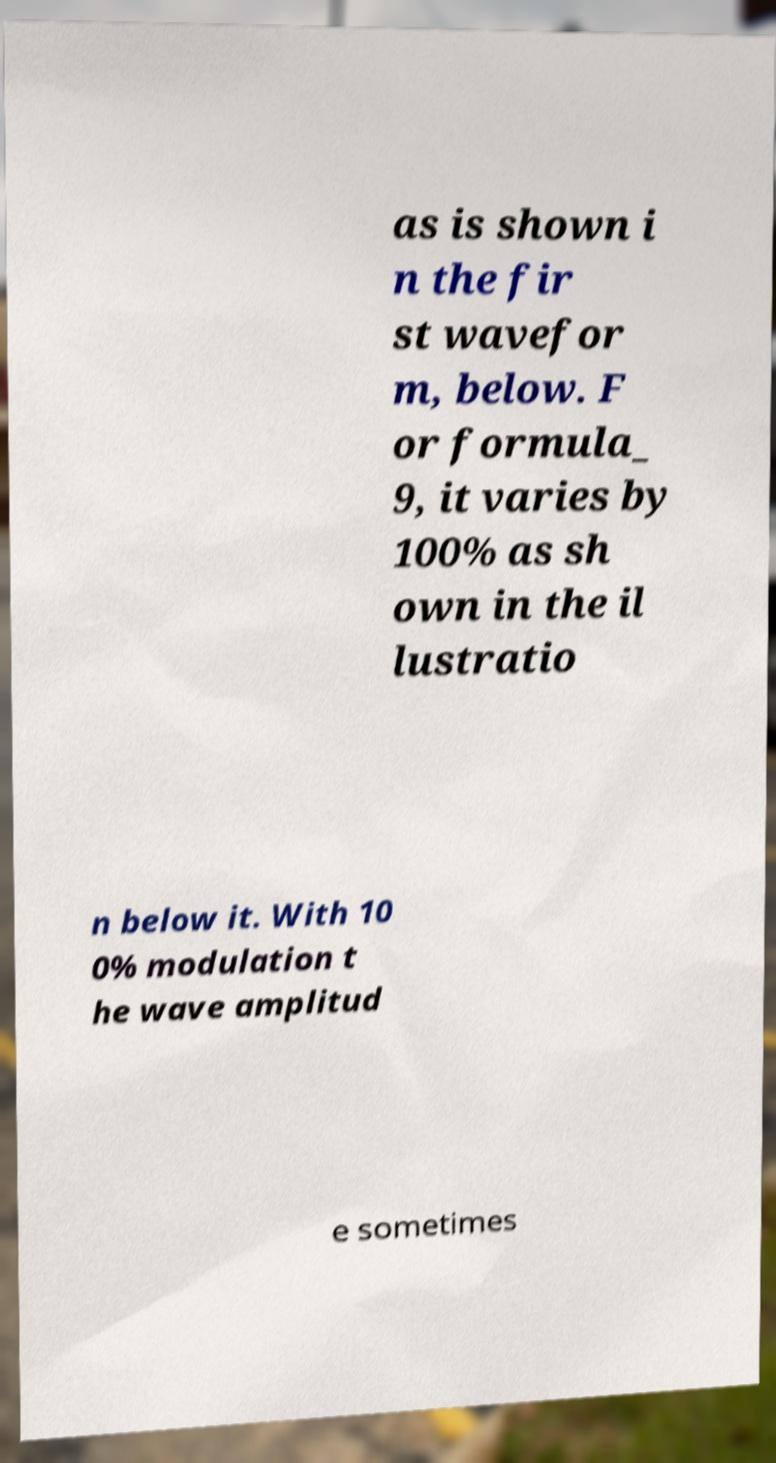There's text embedded in this image that I need extracted. Can you transcribe it verbatim? as is shown i n the fir st wavefor m, below. F or formula_ 9, it varies by 100% as sh own in the il lustratio n below it. With 10 0% modulation t he wave amplitud e sometimes 